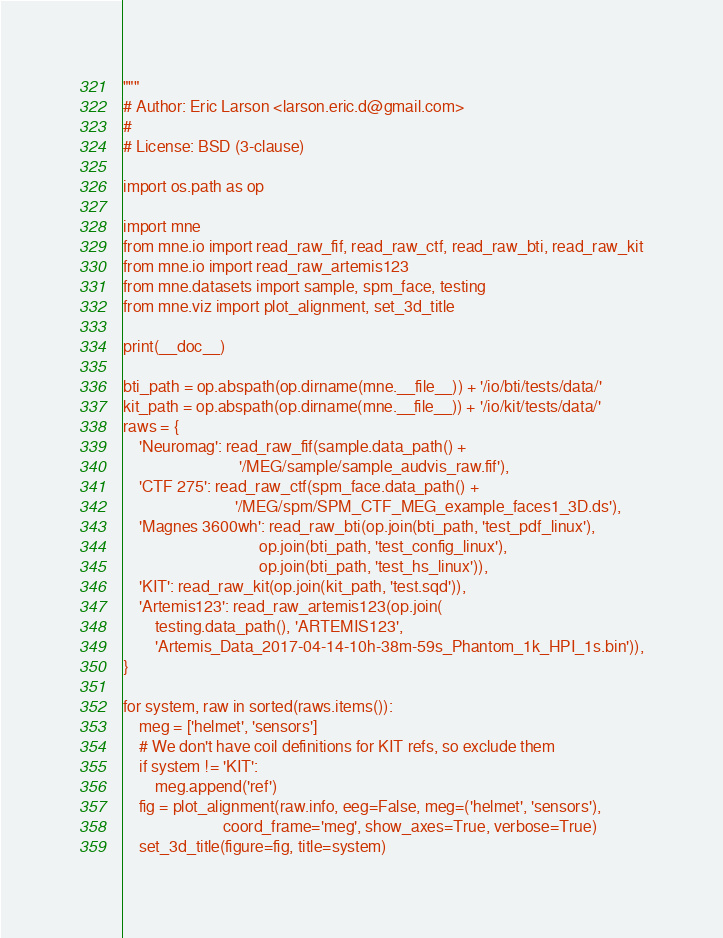<code> <loc_0><loc_0><loc_500><loc_500><_Python_>"""
# Author: Eric Larson <larson.eric.d@gmail.com>
#
# License: BSD (3-clause)

import os.path as op

import mne
from mne.io import read_raw_fif, read_raw_ctf, read_raw_bti, read_raw_kit
from mne.io import read_raw_artemis123
from mne.datasets import sample, spm_face, testing
from mne.viz import plot_alignment, set_3d_title

print(__doc__)

bti_path = op.abspath(op.dirname(mne.__file__)) + '/io/bti/tests/data/'
kit_path = op.abspath(op.dirname(mne.__file__)) + '/io/kit/tests/data/'
raws = {
    'Neuromag': read_raw_fif(sample.data_path() +
                             '/MEG/sample/sample_audvis_raw.fif'),
    'CTF 275': read_raw_ctf(spm_face.data_path() +
                            '/MEG/spm/SPM_CTF_MEG_example_faces1_3D.ds'),
    'Magnes 3600wh': read_raw_bti(op.join(bti_path, 'test_pdf_linux'),
                                  op.join(bti_path, 'test_config_linux'),
                                  op.join(bti_path, 'test_hs_linux')),
    'KIT': read_raw_kit(op.join(kit_path, 'test.sqd')),
    'Artemis123': read_raw_artemis123(op.join(
        testing.data_path(), 'ARTEMIS123',
        'Artemis_Data_2017-04-14-10h-38m-59s_Phantom_1k_HPI_1s.bin')),
}

for system, raw in sorted(raws.items()):
    meg = ['helmet', 'sensors']
    # We don't have coil definitions for KIT refs, so exclude them
    if system != 'KIT':
        meg.append('ref')
    fig = plot_alignment(raw.info, eeg=False, meg=('helmet', 'sensors'),
                         coord_frame='meg', show_axes=True, verbose=True)
    set_3d_title(figure=fig, title=system)
</code> 